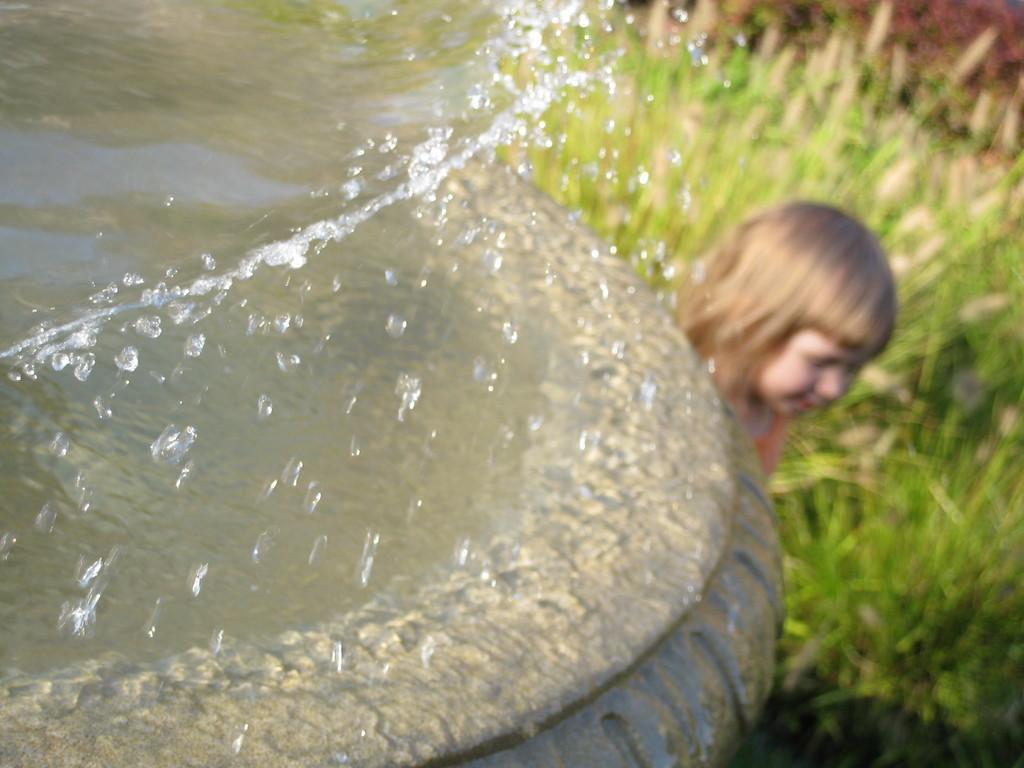Could you give a brief overview of what you see in this image? In the center of the image we can see water in a container. In the background we can see girl and grass. 